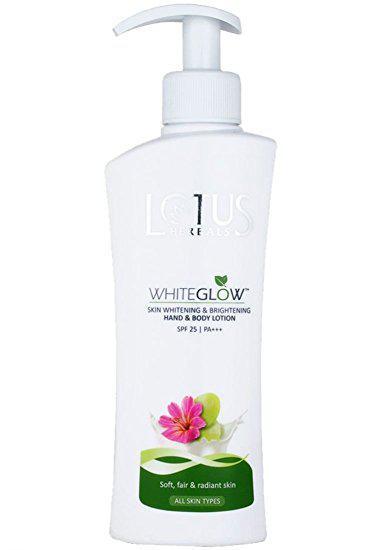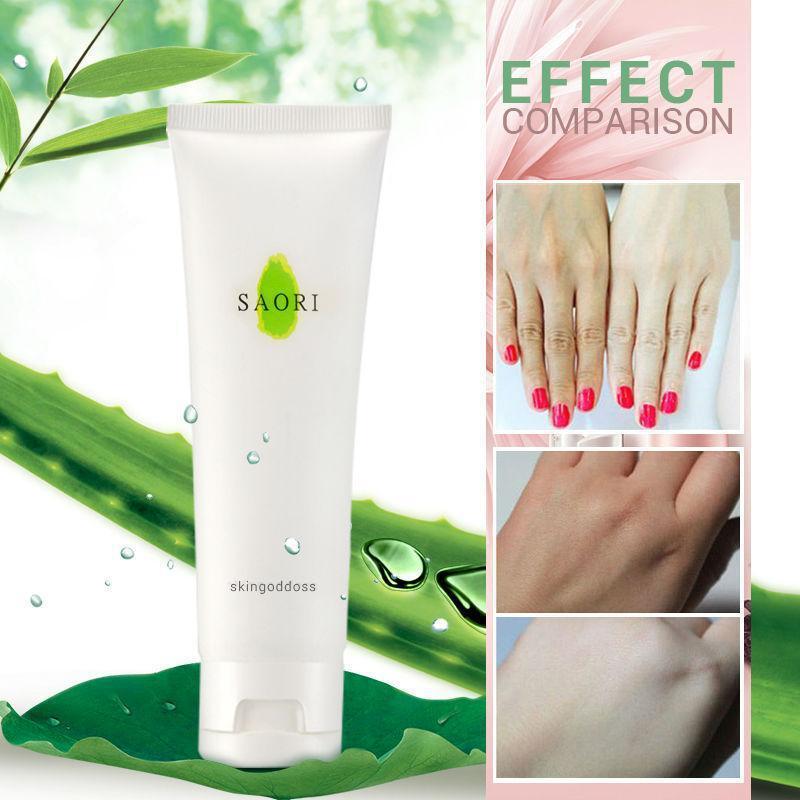The first image is the image on the left, the second image is the image on the right. Considering the images on both sides, is "The right image shows an angled row of at least three lotion products." valid? Answer yes or no. No. 